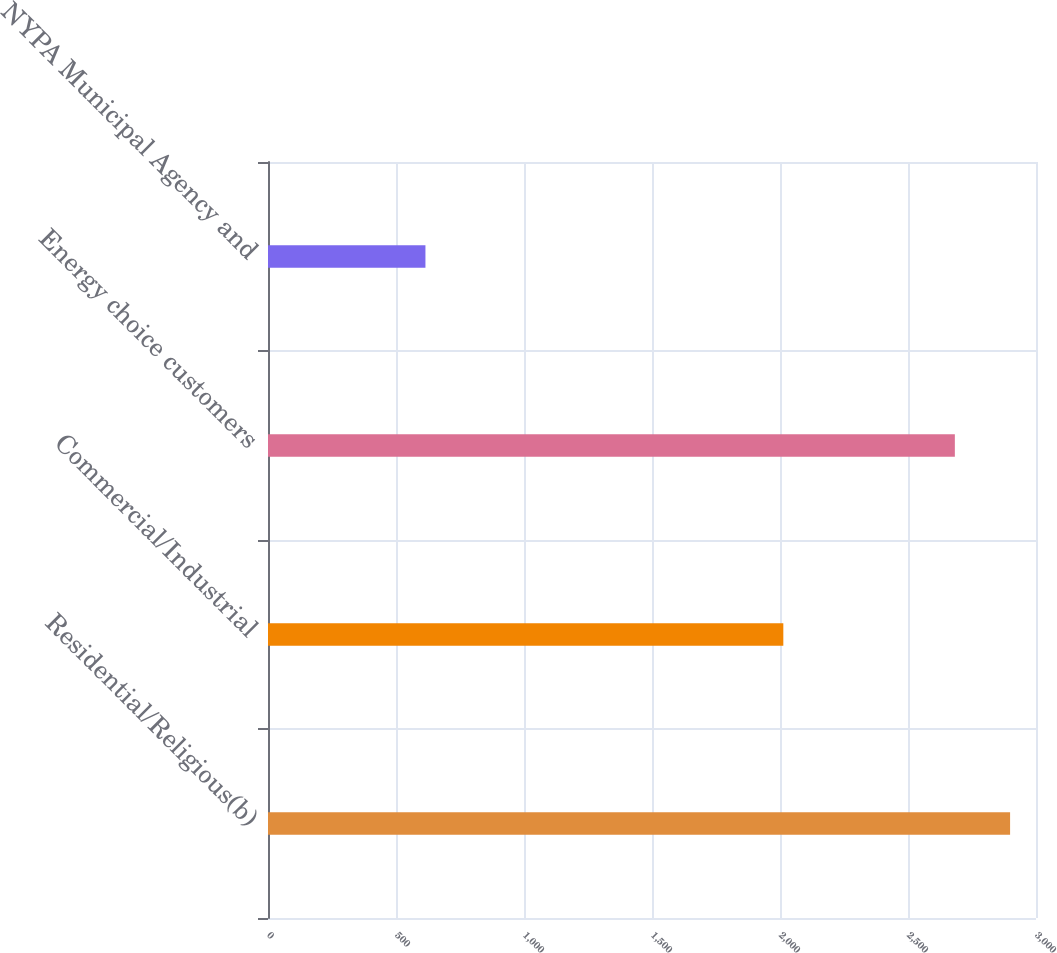<chart> <loc_0><loc_0><loc_500><loc_500><bar_chart><fcel>Residential/Religious(b)<fcel>Commercial/Industrial<fcel>Energy choice customers<fcel>NYPA Municipal Agency and<nl><fcel>2898.8<fcel>2013<fcel>2683<fcel>615<nl></chart> 